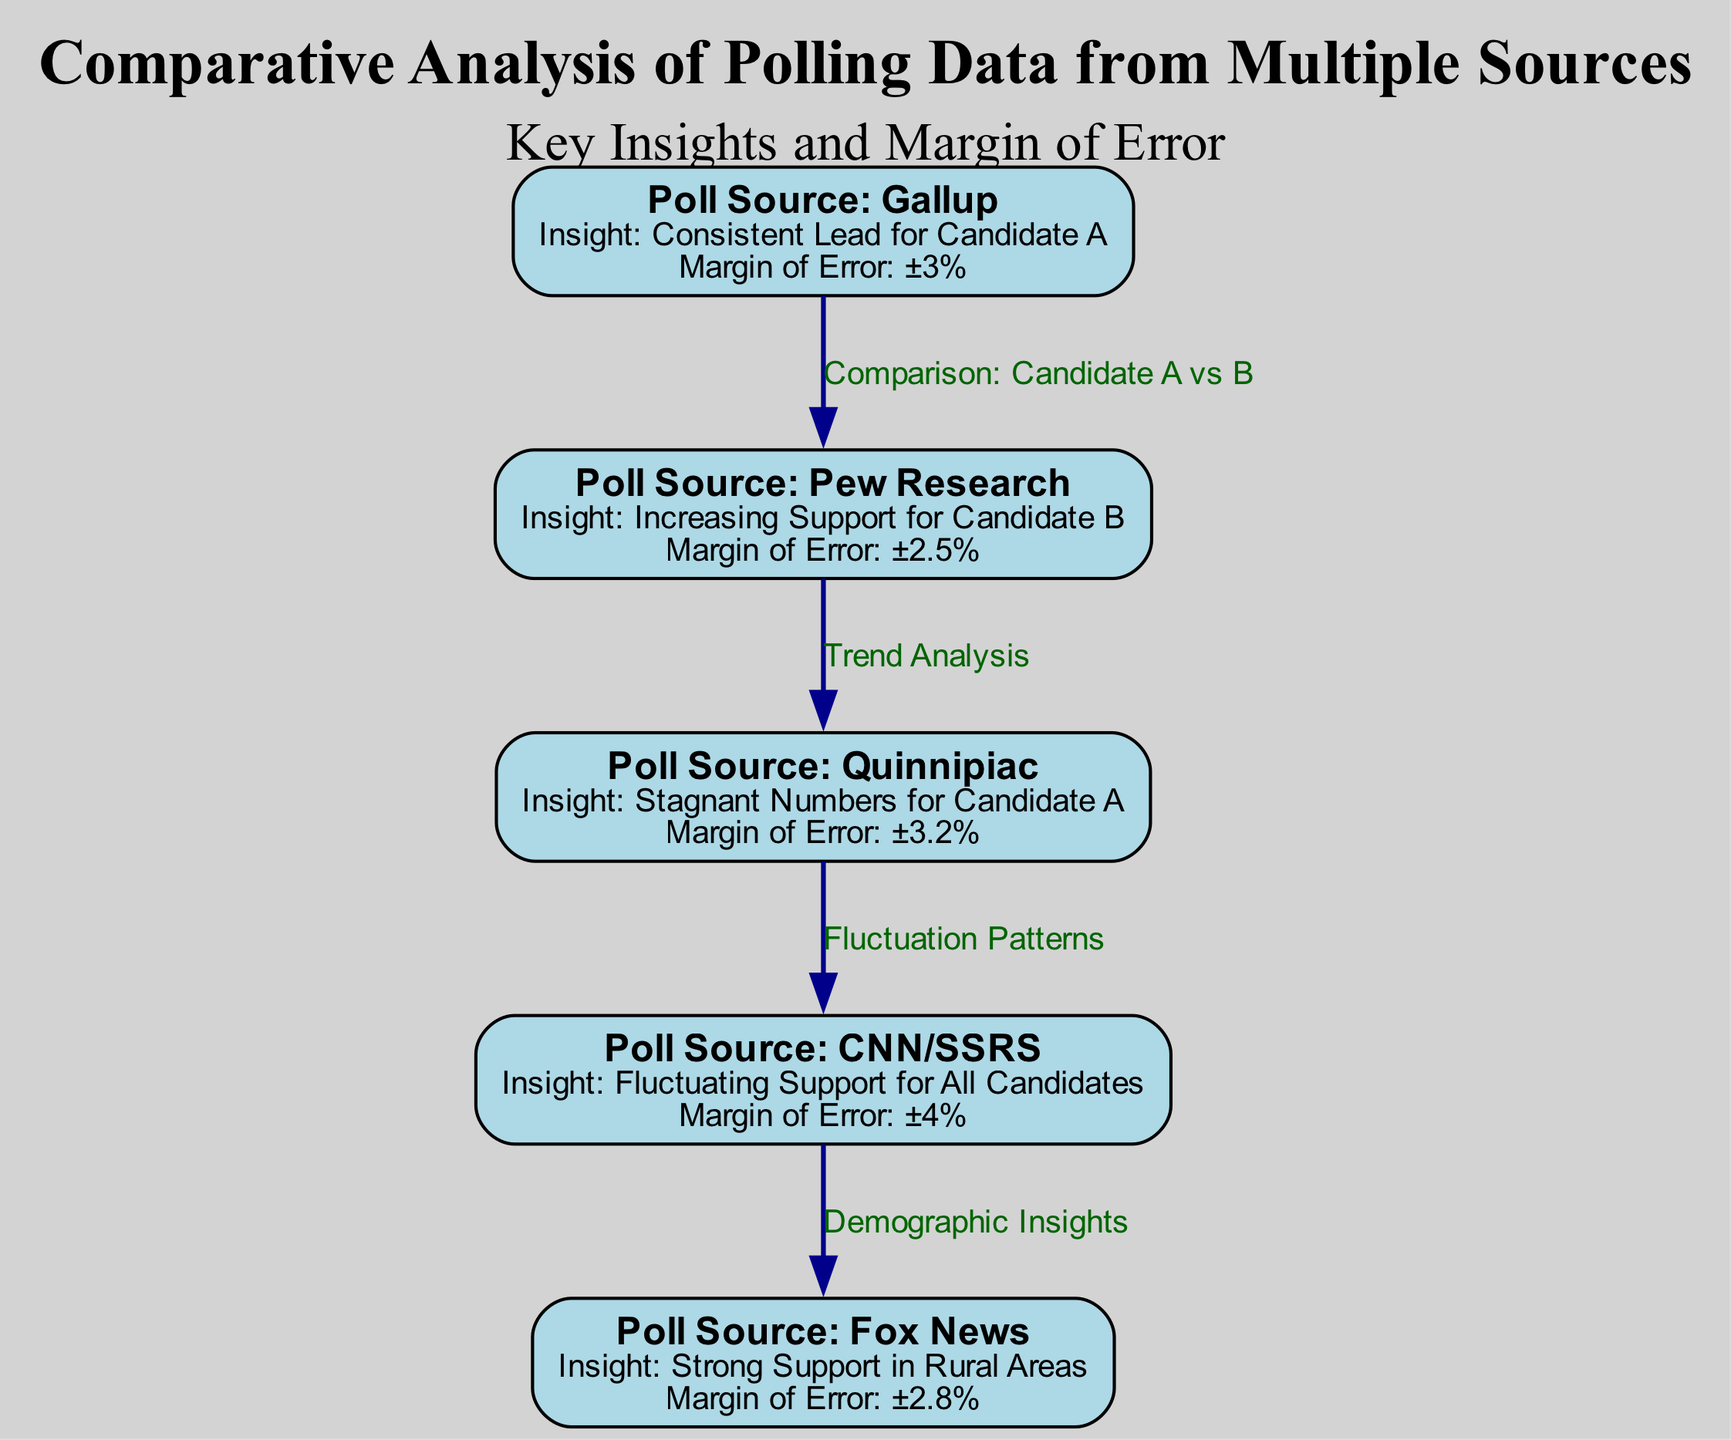What is the margin of error for Pew Research? The diagram states that the margin of error for Pew Research is ±2.5%.
Answer: ±2.5% Which candidate has a consistent lead according to Gallup? The insight from the Gallup poll indicates that Candidate A has a consistent lead.
Answer: Candidate A How many sources are listed in the diagram? The diagram includes a total of five polling sources as nodes.
Answer: 5 What is the insight provided by Fox News? According to Fox News, the insight is that there is strong support in rural areas.
Answer: Strong Support in Rural Areas What type of trend does Quinnipiac show for Candidate A? The diagram indicates that Quinnipiac shows stagnant numbers for Candidate A.
Answer: Stagnant Numbers Are all candidates showing fluctuating support according to CNN/SSRS? The insight from CNN/SSRS states that there is fluctuating support for all candidates, confirming the statement.
Answer: Yes Which polling source shows increasing support for Candidate B? The diagram specifies that Pew Research indicates increasing support for Candidate B.
Answer: Pew Research Which poll has the highest margin of error? The CNN/SSRS poll is stated to have a margin of error of ±4%, which is the highest among the listed sources.
Answer: ±4% What does the connection from Gallup to Pew Research represent? The edge from Gallup to Pew Research represents a comparison between Candidate A and B.
Answer: Comparison: Candidate A vs B Which polling source indicates strong support in rural areas? The diagram explicitly states that Fox News indicates strong support in rural areas.
Answer: Fox News 